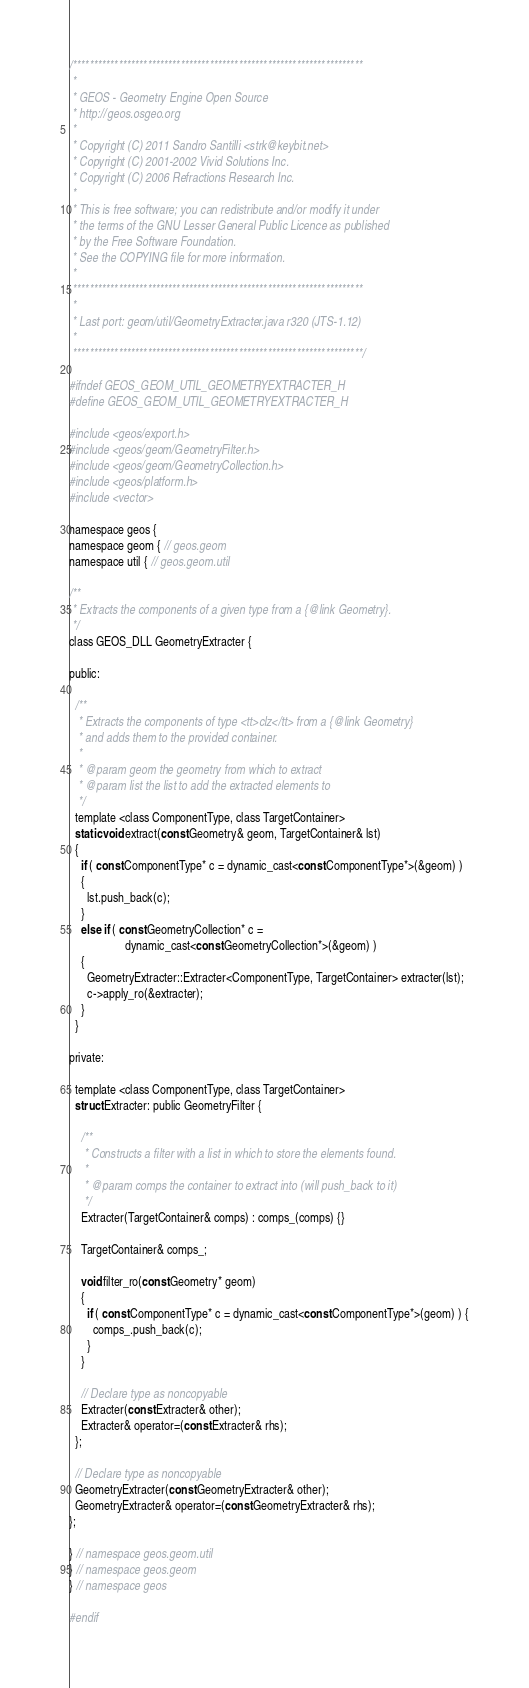Convert code to text. <code><loc_0><loc_0><loc_500><loc_500><_C_>/**********************************************************************
 *
 * GEOS - Geometry Engine Open Source
 * http://geos.osgeo.org
 *
 * Copyright (C) 2011 Sandro Santilli <strk@keybit.net>
 * Copyright (C) 2001-2002 Vivid Solutions Inc.
 * Copyright (C) 2006 Refractions Research Inc.
 *
 * This is free software; you can redistribute and/or modify it under
 * the terms of the GNU Lesser General Public Licence as published
 * by the Free Software Foundation. 
 * See the COPYING file for more information.
 *
 ********************************************************************** 
 *
 * Last port: geom/util/GeometryExtracter.java r320 (JTS-1.12)
 *
 **********************************************************************/

#ifndef GEOS_GEOM_UTIL_GEOMETRYEXTRACTER_H
#define GEOS_GEOM_UTIL_GEOMETRYEXTRACTER_H

#include <geos/export.h>
#include <geos/geom/GeometryFilter.h>
#include <geos/geom/GeometryCollection.h>
#include <geos/platform.h>
#include <vector>

namespace geos {
namespace geom { // geos.geom
namespace util { // geos.geom.util

/**
 * Extracts the components of a given type from a {@link Geometry}.
 */
class GEOS_DLL GeometryExtracter {

public:

  /**
   * Extracts the components of type <tt>clz</tt> from a {@link Geometry}
   * and adds them to the provided container.
   *
   * @param geom the geometry from which to extract
   * @param list the list to add the extracted elements to
   */
  template <class ComponentType, class TargetContainer>
  static void extract(const Geometry& geom, TargetContainer& lst)
  {
    if ( const ComponentType* c = dynamic_cast<const ComponentType*>(&geom) )
    {
      lst.push_back(c);
    }
    else if ( const GeometryCollection* c =
                   dynamic_cast<const GeometryCollection*>(&geom) )
    {
      GeometryExtracter::Extracter<ComponentType, TargetContainer> extracter(lst);
      c->apply_ro(&extracter);
    }
  }

private:

  template <class ComponentType, class TargetContainer>
  struct Extracter: public GeometryFilter {

    /**
     * Constructs a filter with a list in which to store the elements found.
     *
     * @param comps the container to extract into (will push_back to it)
     */
    Extracter(TargetContainer& comps) : comps_(comps) {}

    TargetContainer& comps_;

    void filter_ro(const Geometry* geom)
    {
      if ( const ComponentType* c = dynamic_cast<const ComponentType*>(geom) ) {
        comps_.push_back(c);
      }
    }

    // Declare type as noncopyable
    Extracter(const Extracter& other);
    Extracter& operator=(const Extracter& rhs);
  };

  // Declare type as noncopyable
  GeometryExtracter(const GeometryExtracter& other);
  GeometryExtracter& operator=(const GeometryExtracter& rhs);
};

} // namespace geos.geom.util
} // namespace geos.geom
} // namespace geos

#endif
</code> 